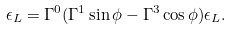<formula> <loc_0><loc_0><loc_500><loc_500>\epsilon _ { L } = \Gamma ^ { 0 } ( \Gamma ^ { 1 } \sin \phi - \Gamma ^ { 3 } \cos \phi ) \epsilon _ { L } .</formula> 